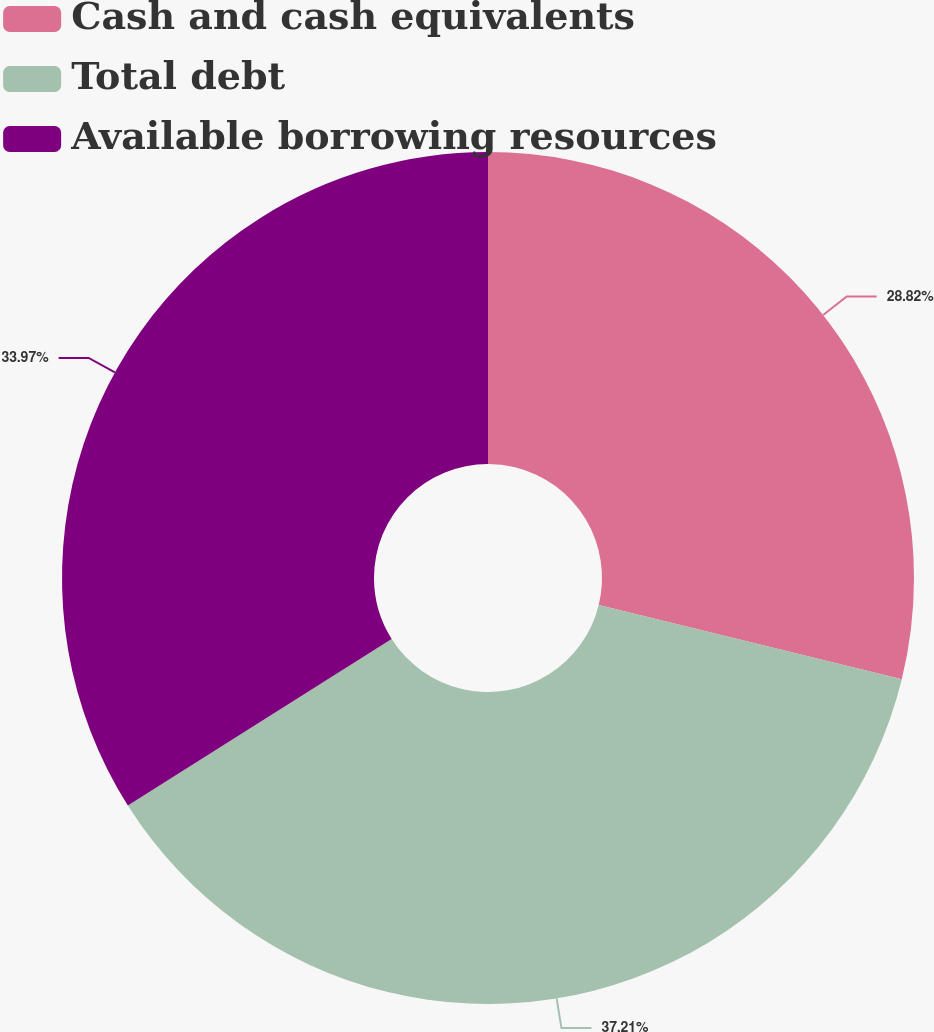Convert chart to OTSL. <chart><loc_0><loc_0><loc_500><loc_500><pie_chart><fcel>Cash and cash equivalents<fcel>Total debt<fcel>Available borrowing resources<nl><fcel>28.82%<fcel>37.21%<fcel>33.97%<nl></chart> 